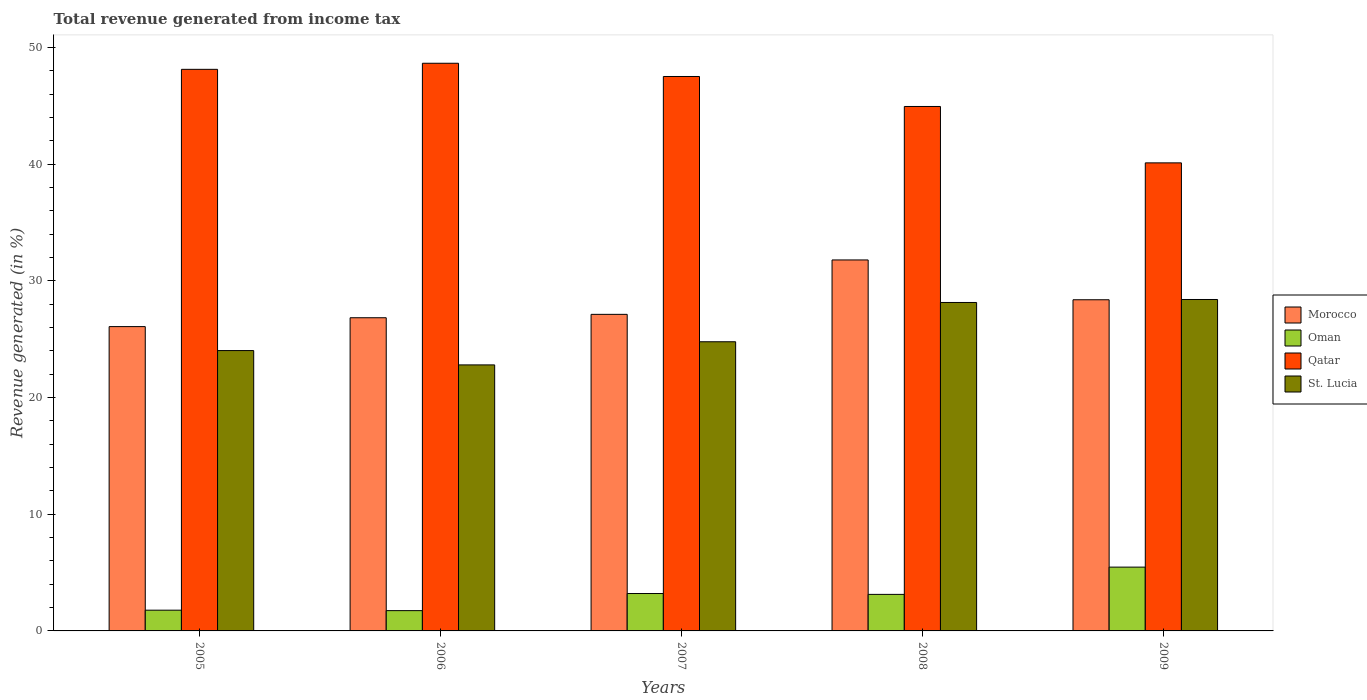How many different coloured bars are there?
Your answer should be compact. 4. How many groups of bars are there?
Your answer should be compact. 5. Are the number of bars per tick equal to the number of legend labels?
Your response must be concise. Yes. How many bars are there on the 3rd tick from the right?
Your answer should be very brief. 4. What is the label of the 2nd group of bars from the left?
Offer a terse response. 2006. What is the total revenue generated in St. Lucia in 2006?
Make the answer very short. 22.8. Across all years, what is the maximum total revenue generated in St. Lucia?
Provide a short and direct response. 28.4. Across all years, what is the minimum total revenue generated in Oman?
Make the answer very short. 1.74. In which year was the total revenue generated in St. Lucia minimum?
Your answer should be very brief. 2006. What is the total total revenue generated in Oman in the graph?
Provide a short and direct response. 15.32. What is the difference between the total revenue generated in Qatar in 2006 and that in 2007?
Offer a terse response. 1.13. What is the difference between the total revenue generated in Qatar in 2008 and the total revenue generated in Oman in 2006?
Offer a very short reply. 43.2. What is the average total revenue generated in Qatar per year?
Ensure brevity in your answer.  45.87. In the year 2008, what is the difference between the total revenue generated in Oman and total revenue generated in Morocco?
Provide a succinct answer. -28.66. What is the ratio of the total revenue generated in Oman in 2006 to that in 2007?
Your answer should be very brief. 0.54. Is the difference between the total revenue generated in Oman in 2005 and 2007 greater than the difference between the total revenue generated in Morocco in 2005 and 2007?
Make the answer very short. No. What is the difference between the highest and the second highest total revenue generated in Qatar?
Offer a very short reply. 0.52. What is the difference between the highest and the lowest total revenue generated in St. Lucia?
Ensure brevity in your answer.  5.61. In how many years, is the total revenue generated in St. Lucia greater than the average total revenue generated in St. Lucia taken over all years?
Your response must be concise. 2. Is it the case that in every year, the sum of the total revenue generated in Oman and total revenue generated in Qatar is greater than the sum of total revenue generated in Morocco and total revenue generated in St. Lucia?
Provide a short and direct response. No. What does the 3rd bar from the left in 2006 represents?
Ensure brevity in your answer.  Qatar. What does the 1st bar from the right in 2006 represents?
Offer a terse response. St. Lucia. Is it the case that in every year, the sum of the total revenue generated in Oman and total revenue generated in Qatar is greater than the total revenue generated in St. Lucia?
Offer a terse response. Yes. How many bars are there?
Make the answer very short. 20. Are all the bars in the graph horizontal?
Make the answer very short. No. What is the difference between two consecutive major ticks on the Y-axis?
Ensure brevity in your answer.  10. Are the values on the major ticks of Y-axis written in scientific E-notation?
Provide a succinct answer. No. How are the legend labels stacked?
Your response must be concise. Vertical. What is the title of the graph?
Make the answer very short. Total revenue generated from income tax. Does "Sierra Leone" appear as one of the legend labels in the graph?
Offer a terse response. No. What is the label or title of the Y-axis?
Provide a succinct answer. Revenue generated (in %). What is the Revenue generated (in %) of Morocco in 2005?
Provide a short and direct response. 26.08. What is the Revenue generated (in %) in Oman in 2005?
Ensure brevity in your answer.  1.78. What is the Revenue generated (in %) in Qatar in 2005?
Give a very brief answer. 48.12. What is the Revenue generated (in %) in St. Lucia in 2005?
Your answer should be very brief. 24.02. What is the Revenue generated (in %) of Morocco in 2006?
Provide a succinct answer. 26.84. What is the Revenue generated (in %) of Oman in 2006?
Provide a short and direct response. 1.74. What is the Revenue generated (in %) in Qatar in 2006?
Give a very brief answer. 48.64. What is the Revenue generated (in %) in St. Lucia in 2006?
Your answer should be very brief. 22.8. What is the Revenue generated (in %) of Morocco in 2007?
Ensure brevity in your answer.  27.13. What is the Revenue generated (in %) of Oman in 2007?
Make the answer very short. 3.2. What is the Revenue generated (in %) of Qatar in 2007?
Your response must be concise. 47.51. What is the Revenue generated (in %) in St. Lucia in 2007?
Make the answer very short. 24.78. What is the Revenue generated (in %) in Morocco in 2008?
Provide a short and direct response. 31.79. What is the Revenue generated (in %) in Oman in 2008?
Give a very brief answer. 3.13. What is the Revenue generated (in %) of Qatar in 2008?
Your answer should be compact. 44.94. What is the Revenue generated (in %) in St. Lucia in 2008?
Offer a very short reply. 28.15. What is the Revenue generated (in %) of Morocco in 2009?
Your answer should be compact. 28.38. What is the Revenue generated (in %) of Oman in 2009?
Offer a terse response. 5.47. What is the Revenue generated (in %) in Qatar in 2009?
Make the answer very short. 40.11. What is the Revenue generated (in %) of St. Lucia in 2009?
Provide a succinct answer. 28.4. Across all years, what is the maximum Revenue generated (in %) of Morocco?
Provide a short and direct response. 31.79. Across all years, what is the maximum Revenue generated (in %) in Oman?
Provide a succinct answer. 5.47. Across all years, what is the maximum Revenue generated (in %) in Qatar?
Your answer should be compact. 48.64. Across all years, what is the maximum Revenue generated (in %) of St. Lucia?
Offer a terse response. 28.4. Across all years, what is the minimum Revenue generated (in %) in Morocco?
Ensure brevity in your answer.  26.08. Across all years, what is the minimum Revenue generated (in %) of Oman?
Ensure brevity in your answer.  1.74. Across all years, what is the minimum Revenue generated (in %) of Qatar?
Keep it short and to the point. 40.11. Across all years, what is the minimum Revenue generated (in %) in St. Lucia?
Provide a short and direct response. 22.8. What is the total Revenue generated (in %) in Morocco in the graph?
Ensure brevity in your answer.  140.21. What is the total Revenue generated (in %) in Oman in the graph?
Offer a very short reply. 15.32. What is the total Revenue generated (in %) of Qatar in the graph?
Give a very brief answer. 229.33. What is the total Revenue generated (in %) in St. Lucia in the graph?
Offer a terse response. 128.14. What is the difference between the Revenue generated (in %) of Morocco in 2005 and that in 2006?
Your answer should be very brief. -0.76. What is the difference between the Revenue generated (in %) in Oman in 2005 and that in 2006?
Your answer should be compact. 0.04. What is the difference between the Revenue generated (in %) of Qatar in 2005 and that in 2006?
Provide a succinct answer. -0.52. What is the difference between the Revenue generated (in %) of St. Lucia in 2005 and that in 2006?
Your answer should be compact. 1.23. What is the difference between the Revenue generated (in %) of Morocco in 2005 and that in 2007?
Make the answer very short. -1.05. What is the difference between the Revenue generated (in %) of Oman in 2005 and that in 2007?
Offer a very short reply. -1.43. What is the difference between the Revenue generated (in %) of Qatar in 2005 and that in 2007?
Keep it short and to the point. 0.61. What is the difference between the Revenue generated (in %) of St. Lucia in 2005 and that in 2007?
Offer a very short reply. -0.76. What is the difference between the Revenue generated (in %) of Morocco in 2005 and that in 2008?
Provide a succinct answer. -5.71. What is the difference between the Revenue generated (in %) of Oman in 2005 and that in 2008?
Ensure brevity in your answer.  -1.35. What is the difference between the Revenue generated (in %) of Qatar in 2005 and that in 2008?
Provide a succinct answer. 3.18. What is the difference between the Revenue generated (in %) of St. Lucia in 2005 and that in 2008?
Provide a succinct answer. -4.12. What is the difference between the Revenue generated (in %) in Morocco in 2005 and that in 2009?
Provide a short and direct response. -2.3. What is the difference between the Revenue generated (in %) of Oman in 2005 and that in 2009?
Offer a very short reply. -3.69. What is the difference between the Revenue generated (in %) in Qatar in 2005 and that in 2009?
Provide a short and direct response. 8.02. What is the difference between the Revenue generated (in %) in St. Lucia in 2005 and that in 2009?
Ensure brevity in your answer.  -4.38. What is the difference between the Revenue generated (in %) of Morocco in 2006 and that in 2007?
Your answer should be compact. -0.29. What is the difference between the Revenue generated (in %) of Oman in 2006 and that in 2007?
Offer a very short reply. -1.47. What is the difference between the Revenue generated (in %) of Qatar in 2006 and that in 2007?
Your answer should be very brief. 1.13. What is the difference between the Revenue generated (in %) in St. Lucia in 2006 and that in 2007?
Offer a terse response. -1.98. What is the difference between the Revenue generated (in %) of Morocco in 2006 and that in 2008?
Offer a very short reply. -4.95. What is the difference between the Revenue generated (in %) of Oman in 2006 and that in 2008?
Ensure brevity in your answer.  -1.39. What is the difference between the Revenue generated (in %) in Qatar in 2006 and that in 2008?
Your answer should be compact. 3.7. What is the difference between the Revenue generated (in %) in St. Lucia in 2006 and that in 2008?
Make the answer very short. -5.35. What is the difference between the Revenue generated (in %) of Morocco in 2006 and that in 2009?
Offer a terse response. -1.54. What is the difference between the Revenue generated (in %) in Oman in 2006 and that in 2009?
Ensure brevity in your answer.  -3.73. What is the difference between the Revenue generated (in %) in Qatar in 2006 and that in 2009?
Give a very brief answer. 8.54. What is the difference between the Revenue generated (in %) in St. Lucia in 2006 and that in 2009?
Keep it short and to the point. -5.61. What is the difference between the Revenue generated (in %) of Morocco in 2007 and that in 2008?
Provide a short and direct response. -4.66. What is the difference between the Revenue generated (in %) of Oman in 2007 and that in 2008?
Give a very brief answer. 0.07. What is the difference between the Revenue generated (in %) in Qatar in 2007 and that in 2008?
Your answer should be compact. 2.57. What is the difference between the Revenue generated (in %) of St. Lucia in 2007 and that in 2008?
Your answer should be very brief. -3.37. What is the difference between the Revenue generated (in %) in Morocco in 2007 and that in 2009?
Provide a short and direct response. -1.25. What is the difference between the Revenue generated (in %) in Oman in 2007 and that in 2009?
Give a very brief answer. -2.26. What is the difference between the Revenue generated (in %) in Qatar in 2007 and that in 2009?
Provide a succinct answer. 7.4. What is the difference between the Revenue generated (in %) of St. Lucia in 2007 and that in 2009?
Your answer should be compact. -3.62. What is the difference between the Revenue generated (in %) in Morocco in 2008 and that in 2009?
Ensure brevity in your answer.  3.41. What is the difference between the Revenue generated (in %) in Oman in 2008 and that in 2009?
Provide a succinct answer. -2.34. What is the difference between the Revenue generated (in %) of Qatar in 2008 and that in 2009?
Provide a succinct answer. 4.83. What is the difference between the Revenue generated (in %) in St. Lucia in 2008 and that in 2009?
Your response must be concise. -0.26. What is the difference between the Revenue generated (in %) in Morocco in 2005 and the Revenue generated (in %) in Oman in 2006?
Keep it short and to the point. 24.34. What is the difference between the Revenue generated (in %) of Morocco in 2005 and the Revenue generated (in %) of Qatar in 2006?
Offer a terse response. -22.57. What is the difference between the Revenue generated (in %) in Morocco in 2005 and the Revenue generated (in %) in St. Lucia in 2006?
Your answer should be compact. 3.28. What is the difference between the Revenue generated (in %) in Oman in 2005 and the Revenue generated (in %) in Qatar in 2006?
Offer a terse response. -46.87. What is the difference between the Revenue generated (in %) of Oman in 2005 and the Revenue generated (in %) of St. Lucia in 2006?
Keep it short and to the point. -21.02. What is the difference between the Revenue generated (in %) of Qatar in 2005 and the Revenue generated (in %) of St. Lucia in 2006?
Offer a terse response. 25.33. What is the difference between the Revenue generated (in %) in Morocco in 2005 and the Revenue generated (in %) in Oman in 2007?
Offer a terse response. 22.87. What is the difference between the Revenue generated (in %) of Morocco in 2005 and the Revenue generated (in %) of Qatar in 2007?
Offer a very short reply. -21.43. What is the difference between the Revenue generated (in %) of Morocco in 2005 and the Revenue generated (in %) of St. Lucia in 2007?
Make the answer very short. 1.3. What is the difference between the Revenue generated (in %) of Oman in 2005 and the Revenue generated (in %) of Qatar in 2007?
Your answer should be compact. -45.73. What is the difference between the Revenue generated (in %) in Oman in 2005 and the Revenue generated (in %) in St. Lucia in 2007?
Ensure brevity in your answer.  -23. What is the difference between the Revenue generated (in %) in Qatar in 2005 and the Revenue generated (in %) in St. Lucia in 2007?
Offer a terse response. 23.34. What is the difference between the Revenue generated (in %) of Morocco in 2005 and the Revenue generated (in %) of Oman in 2008?
Provide a short and direct response. 22.95. What is the difference between the Revenue generated (in %) in Morocco in 2005 and the Revenue generated (in %) in Qatar in 2008?
Provide a short and direct response. -18.86. What is the difference between the Revenue generated (in %) in Morocco in 2005 and the Revenue generated (in %) in St. Lucia in 2008?
Your answer should be compact. -2.07. What is the difference between the Revenue generated (in %) of Oman in 2005 and the Revenue generated (in %) of Qatar in 2008?
Keep it short and to the point. -43.16. What is the difference between the Revenue generated (in %) of Oman in 2005 and the Revenue generated (in %) of St. Lucia in 2008?
Your response must be concise. -26.37. What is the difference between the Revenue generated (in %) of Qatar in 2005 and the Revenue generated (in %) of St. Lucia in 2008?
Your answer should be very brief. 19.98. What is the difference between the Revenue generated (in %) in Morocco in 2005 and the Revenue generated (in %) in Oman in 2009?
Give a very brief answer. 20.61. What is the difference between the Revenue generated (in %) of Morocco in 2005 and the Revenue generated (in %) of Qatar in 2009?
Keep it short and to the point. -14.03. What is the difference between the Revenue generated (in %) of Morocco in 2005 and the Revenue generated (in %) of St. Lucia in 2009?
Give a very brief answer. -2.32. What is the difference between the Revenue generated (in %) in Oman in 2005 and the Revenue generated (in %) in Qatar in 2009?
Your answer should be compact. -38.33. What is the difference between the Revenue generated (in %) of Oman in 2005 and the Revenue generated (in %) of St. Lucia in 2009?
Offer a very short reply. -26.62. What is the difference between the Revenue generated (in %) in Qatar in 2005 and the Revenue generated (in %) in St. Lucia in 2009?
Your response must be concise. 19.72. What is the difference between the Revenue generated (in %) of Morocco in 2006 and the Revenue generated (in %) of Oman in 2007?
Your response must be concise. 23.63. What is the difference between the Revenue generated (in %) in Morocco in 2006 and the Revenue generated (in %) in Qatar in 2007?
Your answer should be very brief. -20.67. What is the difference between the Revenue generated (in %) of Morocco in 2006 and the Revenue generated (in %) of St. Lucia in 2007?
Make the answer very short. 2.06. What is the difference between the Revenue generated (in %) in Oman in 2006 and the Revenue generated (in %) in Qatar in 2007?
Keep it short and to the point. -45.77. What is the difference between the Revenue generated (in %) in Oman in 2006 and the Revenue generated (in %) in St. Lucia in 2007?
Provide a succinct answer. -23.04. What is the difference between the Revenue generated (in %) of Qatar in 2006 and the Revenue generated (in %) of St. Lucia in 2007?
Ensure brevity in your answer.  23.87. What is the difference between the Revenue generated (in %) of Morocco in 2006 and the Revenue generated (in %) of Oman in 2008?
Offer a terse response. 23.71. What is the difference between the Revenue generated (in %) of Morocco in 2006 and the Revenue generated (in %) of Qatar in 2008?
Make the answer very short. -18.1. What is the difference between the Revenue generated (in %) in Morocco in 2006 and the Revenue generated (in %) in St. Lucia in 2008?
Offer a very short reply. -1.31. What is the difference between the Revenue generated (in %) in Oman in 2006 and the Revenue generated (in %) in Qatar in 2008?
Ensure brevity in your answer.  -43.2. What is the difference between the Revenue generated (in %) of Oman in 2006 and the Revenue generated (in %) of St. Lucia in 2008?
Make the answer very short. -26.41. What is the difference between the Revenue generated (in %) of Qatar in 2006 and the Revenue generated (in %) of St. Lucia in 2008?
Provide a succinct answer. 20.5. What is the difference between the Revenue generated (in %) of Morocco in 2006 and the Revenue generated (in %) of Oman in 2009?
Your answer should be compact. 21.37. What is the difference between the Revenue generated (in %) of Morocco in 2006 and the Revenue generated (in %) of Qatar in 2009?
Your answer should be compact. -13.27. What is the difference between the Revenue generated (in %) of Morocco in 2006 and the Revenue generated (in %) of St. Lucia in 2009?
Make the answer very short. -1.56. What is the difference between the Revenue generated (in %) of Oman in 2006 and the Revenue generated (in %) of Qatar in 2009?
Provide a succinct answer. -38.37. What is the difference between the Revenue generated (in %) of Oman in 2006 and the Revenue generated (in %) of St. Lucia in 2009?
Ensure brevity in your answer.  -26.66. What is the difference between the Revenue generated (in %) of Qatar in 2006 and the Revenue generated (in %) of St. Lucia in 2009?
Your answer should be compact. 20.24. What is the difference between the Revenue generated (in %) of Morocco in 2007 and the Revenue generated (in %) of Oman in 2008?
Ensure brevity in your answer.  24. What is the difference between the Revenue generated (in %) of Morocco in 2007 and the Revenue generated (in %) of Qatar in 2008?
Your answer should be very brief. -17.81. What is the difference between the Revenue generated (in %) in Morocco in 2007 and the Revenue generated (in %) in St. Lucia in 2008?
Give a very brief answer. -1.02. What is the difference between the Revenue generated (in %) of Oman in 2007 and the Revenue generated (in %) of Qatar in 2008?
Keep it short and to the point. -41.74. What is the difference between the Revenue generated (in %) in Oman in 2007 and the Revenue generated (in %) in St. Lucia in 2008?
Keep it short and to the point. -24.94. What is the difference between the Revenue generated (in %) in Qatar in 2007 and the Revenue generated (in %) in St. Lucia in 2008?
Your response must be concise. 19.36. What is the difference between the Revenue generated (in %) of Morocco in 2007 and the Revenue generated (in %) of Oman in 2009?
Keep it short and to the point. 21.66. What is the difference between the Revenue generated (in %) of Morocco in 2007 and the Revenue generated (in %) of Qatar in 2009?
Ensure brevity in your answer.  -12.98. What is the difference between the Revenue generated (in %) in Morocco in 2007 and the Revenue generated (in %) in St. Lucia in 2009?
Your answer should be compact. -1.27. What is the difference between the Revenue generated (in %) in Oman in 2007 and the Revenue generated (in %) in Qatar in 2009?
Your answer should be compact. -36.9. What is the difference between the Revenue generated (in %) of Oman in 2007 and the Revenue generated (in %) of St. Lucia in 2009?
Offer a very short reply. -25.2. What is the difference between the Revenue generated (in %) of Qatar in 2007 and the Revenue generated (in %) of St. Lucia in 2009?
Give a very brief answer. 19.11. What is the difference between the Revenue generated (in %) in Morocco in 2008 and the Revenue generated (in %) in Oman in 2009?
Keep it short and to the point. 26.32. What is the difference between the Revenue generated (in %) of Morocco in 2008 and the Revenue generated (in %) of Qatar in 2009?
Make the answer very short. -8.32. What is the difference between the Revenue generated (in %) of Morocco in 2008 and the Revenue generated (in %) of St. Lucia in 2009?
Your response must be concise. 3.39. What is the difference between the Revenue generated (in %) in Oman in 2008 and the Revenue generated (in %) in Qatar in 2009?
Offer a terse response. -36.98. What is the difference between the Revenue generated (in %) in Oman in 2008 and the Revenue generated (in %) in St. Lucia in 2009?
Provide a short and direct response. -25.27. What is the difference between the Revenue generated (in %) in Qatar in 2008 and the Revenue generated (in %) in St. Lucia in 2009?
Provide a succinct answer. 16.54. What is the average Revenue generated (in %) in Morocco per year?
Provide a succinct answer. 28.04. What is the average Revenue generated (in %) in Oman per year?
Provide a short and direct response. 3.06. What is the average Revenue generated (in %) in Qatar per year?
Keep it short and to the point. 45.87. What is the average Revenue generated (in %) in St. Lucia per year?
Make the answer very short. 25.63. In the year 2005, what is the difference between the Revenue generated (in %) in Morocco and Revenue generated (in %) in Oman?
Offer a very short reply. 24.3. In the year 2005, what is the difference between the Revenue generated (in %) in Morocco and Revenue generated (in %) in Qatar?
Give a very brief answer. -22.05. In the year 2005, what is the difference between the Revenue generated (in %) in Morocco and Revenue generated (in %) in St. Lucia?
Offer a terse response. 2.05. In the year 2005, what is the difference between the Revenue generated (in %) of Oman and Revenue generated (in %) of Qatar?
Your response must be concise. -46.35. In the year 2005, what is the difference between the Revenue generated (in %) in Oman and Revenue generated (in %) in St. Lucia?
Keep it short and to the point. -22.25. In the year 2005, what is the difference between the Revenue generated (in %) of Qatar and Revenue generated (in %) of St. Lucia?
Your answer should be very brief. 24.1. In the year 2006, what is the difference between the Revenue generated (in %) in Morocco and Revenue generated (in %) in Oman?
Keep it short and to the point. 25.1. In the year 2006, what is the difference between the Revenue generated (in %) in Morocco and Revenue generated (in %) in Qatar?
Offer a very short reply. -21.81. In the year 2006, what is the difference between the Revenue generated (in %) in Morocco and Revenue generated (in %) in St. Lucia?
Offer a very short reply. 4.04. In the year 2006, what is the difference between the Revenue generated (in %) of Oman and Revenue generated (in %) of Qatar?
Ensure brevity in your answer.  -46.91. In the year 2006, what is the difference between the Revenue generated (in %) of Oman and Revenue generated (in %) of St. Lucia?
Keep it short and to the point. -21.06. In the year 2006, what is the difference between the Revenue generated (in %) in Qatar and Revenue generated (in %) in St. Lucia?
Offer a very short reply. 25.85. In the year 2007, what is the difference between the Revenue generated (in %) of Morocco and Revenue generated (in %) of Oman?
Offer a very short reply. 23.92. In the year 2007, what is the difference between the Revenue generated (in %) of Morocco and Revenue generated (in %) of Qatar?
Offer a very short reply. -20.38. In the year 2007, what is the difference between the Revenue generated (in %) of Morocco and Revenue generated (in %) of St. Lucia?
Make the answer very short. 2.35. In the year 2007, what is the difference between the Revenue generated (in %) of Oman and Revenue generated (in %) of Qatar?
Provide a succinct answer. -44.31. In the year 2007, what is the difference between the Revenue generated (in %) of Oman and Revenue generated (in %) of St. Lucia?
Provide a short and direct response. -21.57. In the year 2007, what is the difference between the Revenue generated (in %) of Qatar and Revenue generated (in %) of St. Lucia?
Ensure brevity in your answer.  22.73. In the year 2008, what is the difference between the Revenue generated (in %) of Morocco and Revenue generated (in %) of Oman?
Provide a succinct answer. 28.66. In the year 2008, what is the difference between the Revenue generated (in %) in Morocco and Revenue generated (in %) in Qatar?
Your response must be concise. -13.15. In the year 2008, what is the difference between the Revenue generated (in %) in Morocco and Revenue generated (in %) in St. Lucia?
Your answer should be compact. 3.65. In the year 2008, what is the difference between the Revenue generated (in %) of Oman and Revenue generated (in %) of Qatar?
Give a very brief answer. -41.81. In the year 2008, what is the difference between the Revenue generated (in %) of Oman and Revenue generated (in %) of St. Lucia?
Your answer should be compact. -25.02. In the year 2008, what is the difference between the Revenue generated (in %) of Qatar and Revenue generated (in %) of St. Lucia?
Give a very brief answer. 16.8. In the year 2009, what is the difference between the Revenue generated (in %) of Morocco and Revenue generated (in %) of Oman?
Your answer should be compact. 22.91. In the year 2009, what is the difference between the Revenue generated (in %) of Morocco and Revenue generated (in %) of Qatar?
Provide a succinct answer. -11.73. In the year 2009, what is the difference between the Revenue generated (in %) in Morocco and Revenue generated (in %) in St. Lucia?
Offer a very short reply. -0.02. In the year 2009, what is the difference between the Revenue generated (in %) of Oman and Revenue generated (in %) of Qatar?
Provide a short and direct response. -34.64. In the year 2009, what is the difference between the Revenue generated (in %) in Oman and Revenue generated (in %) in St. Lucia?
Keep it short and to the point. -22.93. In the year 2009, what is the difference between the Revenue generated (in %) of Qatar and Revenue generated (in %) of St. Lucia?
Keep it short and to the point. 11.71. What is the ratio of the Revenue generated (in %) in Morocco in 2005 to that in 2006?
Offer a very short reply. 0.97. What is the ratio of the Revenue generated (in %) in Oman in 2005 to that in 2006?
Keep it short and to the point. 1.02. What is the ratio of the Revenue generated (in %) of Qatar in 2005 to that in 2006?
Your response must be concise. 0.99. What is the ratio of the Revenue generated (in %) in St. Lucia in 2005 to that in 2006?
Offer a terse response. 1.05. What is the ratio of the Revenue generated (in %) of Morocco in 2005 to that in 2007?
Your response must be concise. 0.96. What is the ratio of the Revenue generated (in %) in Oman in 2005 to that in 2007?
Ensure brevity in your answer.  0.55. What is the ratio of the Revenue generated (in %) in Qatar in 2005 to that in 2007?
Keep it short and to the point. 1.01. What is the ratio of the Revenue generated (in %) in St. Lucia in 2005 to that in 2007?
Offer a very short reply. 0.97. What is the ratio of the Revenue generated (in %) in Morocco in 2005 to that in 2008?
Your answer should be very brief. 0.82. What is the ratio of the Revenue generated (in %) of Oman in 2005 to that in 2008?
Your response must be concise. 0.57. What is the ratio of the Revenue generated (in %) in Qatar in 2005 to that in 2008?
Offer a very short reply. 1.07. What is the ratio of the Revenue generated (in %) in St. Lucia in 2005 to that in 2008?
Provide a short and direct response. 0.85. What is the ratio of the Revenue generated (in %) of Morocco in 2005 to that in 2009?
Your response must be concise. 0.92. What is the ratio of the Revenue generated (in %) of Oman in 2005 to that in 2009?
Your response must be concise. 0.33. What is the ratio of the Revenue generated (in %) in Qatar in 2005 to that in 2009?
Ensure brevity in your answer.  1.2. What is the ratio of the Revenue generated (in %) of St. Lucia in 2005 to that in 2009?
Provide a short and direct response. 0.85. What is the ratio of the Revenue generated (in %) of Morocco in 2006 to that in 2007?
Give a very brief answer. 0.99. What is the ratio of the Revenue generated (in %) in Oman in 2006 to that in 2007?
Your answer should be compact. 0.54. What is the ratio of the Revenue generated (in %) of Qatar in 2006 to that in 2007?
Your answer should be compact. 1.02. What is the ratio of the Revenue generated (in %) of Morocco in 2006 to that in 2008?
Keep it short and to the point. 0.84. What is the ratio of the Revenue generated (in %) of Oman in 2006 to that in 2008?
Your answer should be very brief. 0.56. What is the ratio of the Revenue generated (in %) of Qatar in 2006 to that in 2008?
Offer a very short reply. 1.08. What is the ratio of the Revenue generated (in %) in St. Lucia in 2006 to that in 2008?
Ensure brevity in your answer.  0.81. What is the ratio of the Revenue generated (in %) of Morocco in 2006 to that in 2009?
Provide a short and direct response. 0.95. What is the ratio of the Revenue generated (in %) of Oman in 2006 to that in 2009?
Provide a short and direct response. 0.32. What is the ratio of the Revenue generated (in %) in Qatar in 2006 to that in 2009?
Offer a terse response. 1.21. What is the ratio of the Revenue generated (in %) in St. Lucia in 2006 to that in 2009?
Your answer should be very brief. 0.8. What is the ratio of the Revenue generated (in %) of Morocco in 2007 to that in 2008?
Offer a very short reply. 0.85. What is the ratio of the Revenue generated (in %) in Oman in 2007 to that in 2008?
Offer a very short reply. 1.02. What is the ratio of the Revenue generated (in %) in Qatar in 2007 to that in 2008?
Make the answer very short. 1.06. What is the ratio of the Revenue generated (in %) in St. Lucia in 2007 to that in 2008?
Your response must be concise. 0.88. What is the ratio of the Revenue generated (in %) of Morocco in 2007 to that in 2009?
Offer a very short reply. 0.96. What is the ratio of the Revenue generated (in %) in Oman in 2007 to that in 2009?
Keep it short and to the point. 0.59. What is the ratio of the Revenue generated (in %) in Qatar in 2007 to that in 2009?
Provide a succinct answer. 1.18. What is the ratio of the Revenue generated (in %) in St. Lucia in 2007 to that in 2009?
Your answer should be compact. 0.87. What is the ratio of the Revenue generated (in %) in Morocco in 2008 to that in 2009?
Your response must be concise. 1.12. What is the ratio of the Revenue generated (in %) of Oman in 2008 to that in 2009?
Ensure brevity in your answer.  0.57. What is the ratio of the Revenue generated (in %) of Qatar in 2008 to that in 2009?
Your answer should be very brief. 1.12. What is the ratio of the Revenue generated (in %) in St. Lucia in 2008 to that in 2009?
Make the answer very short. 0.99. What is the difference between the highest and the second highest Revenue generated (in %) in Morocco?
Your response must be concise. 3.41. What is the difference between the highest and the second highest Revenue generated (in %) in Oman?
Your answer should be compact. 2.26. What is the difference between the highest and the second highest Revenue generated (in %) in Qatar?
Your answer should be compact. 0.52. What is the difference between the highest and the second highest Revenue generated (in %) in St. Lucia?
Offer a terse response. 0.26. What is the difference between the highest and the lowest Revenue generated (in %) in Morocco?
Provide a succinct answer. 5.71. What is the difference between the highest and the lowest Revenue generated (in %) in Oman?
Make the answer very short. 3.73. What is the difference between the highest and the lowest Revenue generated (in %) of Qatar?
Make the answer very short. 8.54. What is the difference between the highest and the lowest Revenue generated (in %) of St. Lucia?
Provide a short and direct response. 5.61. 